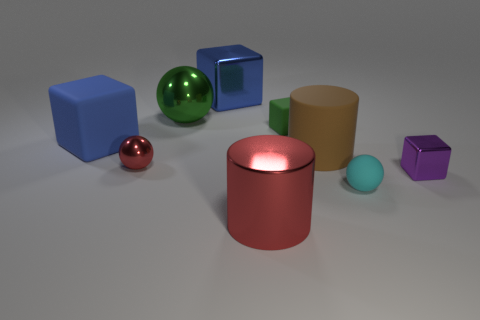There is a blue block that is the same material as the tiny green cube; what is its size?
Offer a very short reply. Large. What is the shape of the small matte object that is on the right side of the big cylinder behind the small red thing?
Provide a succinct answer. Sphere. What is the size of the ball that is in front of the large brown object and behind the tiny cyan matte ball?
Provide a succinct answer. Small. Is there a large brown object of the same shape as the green matte object?
Make the answer very short. No. Is there anything else that has the same shape as the blue rubber thing?
Your response must be concise. Yes. The large blue cube on the right side of the blue thing in front of the tiny thing that is behind the small metal ball is made of what material?
Offer a terse response. Metal. Are there any blue matte things that have the same size as the red sphere?
Provide a short and direct response. No. What is the color of the tiny metal object right of the red metal object that is behind the small cyan sphere?
Your answer should be very brief. Purple. What number of small cyan matte balls are there?
Provide a short and direct response. 1. Does the big ball have the same color as the big metal cylinder?
Your response must be concise. No. 